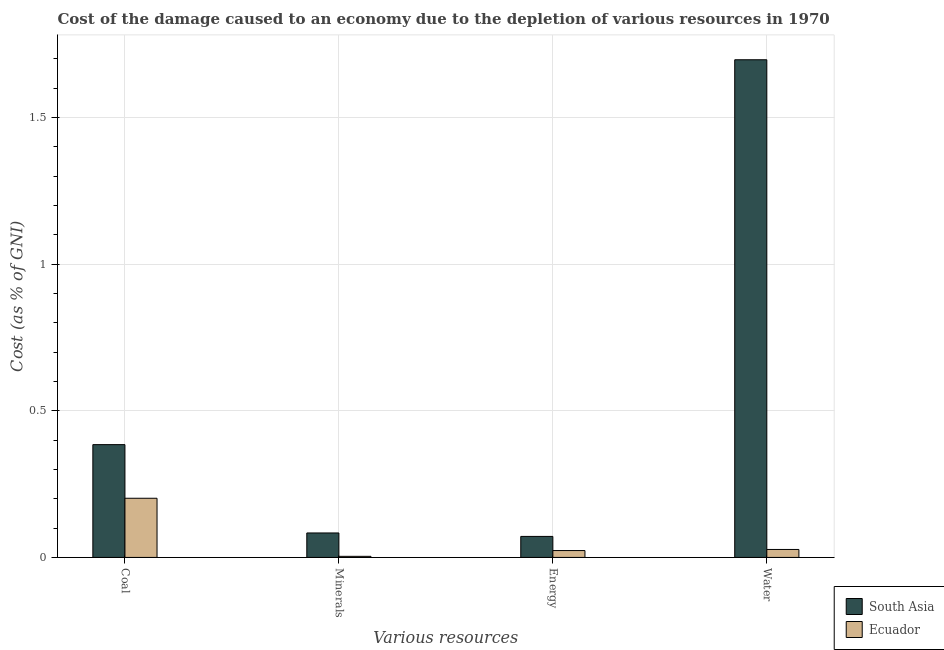How many different coloured bars are there?
Your answer should be compact. 2. Are the number of bars on each tick of the X-axis equal?
Give a very brief answer. Yes. How many bars are there on the 3rd tick from the right?
Your answer should be very brief. 2. What is the label of the 2nd group of bars from the left?
Offer a terse response. Minerals. What is the cost of damage due to depletion of water in Ecuador?
Ensure brevity in your answer.  0.03. Across all countries, what is the maximum cost of damage due to depletion of coal?
Your answer should be very brief. 0.38. Across all countries, what is the minimum cost of damage due to depletion of energy?
Ensure brevity in your answer.  0.02. In which country was the cost of damage due to depletion of minerals minimum?
Offer a very short reply. Ecuador. What is the total cost of damage due to depletion of water in the graph?
Your answer should be very brief. 1.72. What is the difference between the cost of damage due to depletion of coal in Ecuador and that in South Asia?
Offer a very short reply. -0.18. What is the difference between the cost of damage due to depletion of water in Ecuador and the cost of damage due to depletion of coal in South Asia?
Provide a short and direct response. -0.36. What is the average cost of damage due to depletion of minerals per country?
Your answer should be very brief. 0.04. What is the difference between the cost of damage due to depletion of energy and cost of damage due to depletion of minerals in Ecuador?
Your answer should be compact. 0.02. In how many countries, is the cost of damage due to depletion of water greater than 0.1 %?
Offer a very short reply. 1. What is the ratio of the cost of damage due to depletion of water in Ecuador to that in South Asia?
Your answer should be very brief. 0.02. What is the difference between the highest and the second highest cost of damage due to depletion of energy?
Your answer should be compact. 0.05. What is the difference between the highest and the lowest cost of damage due to depletion of minerals?
Make the answer very short. 0.08. In how many countries, is the cost of damage due to depletion of coal greater than the average cost of damage due to depletion of coal taken over all countries?
Your answer should be compact. 1. Is the sum of the cost of damage due to depletion of coal in Ecuador and South Asia greater than the maximum cost of damage due to depletion of water across all countries?
Provide a succinct answer. No. What does the 1st bar from the left in Energy represents?
Give a very brief answer. South Asia. What does the 1st bar from the right in Coal represents?
Your answer should be compact. Ecuador. How many countries are there in the graph?
Give a very brief answer. 2. Are the values on the major ticks of Y-axis written in scientific E-notation?
Make the answer very short. No. Does the graph contain any zero values?
Offer a very short reply. No. Where does the legend appear in the graph?
Offer a terse response. Bottom right. What is the title of the graph?
Give a very brief answer. Cost of the damage caused to an economy due to the depletion of various resources in 1970 . What is the label or title of the X-axis?
Your answer should be very brief. Various resources. What is the label or title of the Y-axis?
Offer a terse response. Cost (as % of GNI). What is the Cost (as % of GNI) of South Asia in Coal?
Offer a very short reply. 0.38. What is the Cost (as % of GNI) in Ecuador in Coal?
Your answer should be very brief. 0.2. What is the Cost (as % of GNI) in South Asia in Minerals?
Give a very brief answer. 0.08. What is the Cost (as % of GNI) in Ecuador in Minerals?
Provide a short and direct response. 0. What is the Cost (as % of GNI) of South Asia in Energy?
Provide a succinct answer. 0.07. What is the Cost (as % of GNI) in Ecuador in Energy?
Keep it short and to the point. 0.02. What is the Cost (as % of GNI) in South Asia in Water?
Make the answer very short. 1.7. What is the Cost (as % of GNI) of Ecuador in Water?
Provide a short and direct response. 0.03. Across all Various resources, what is the maximum Cost (as % of GNI) in South Asia?
Ensure brevity in your answer.  1.7. Across all Various resources, what is the maximum Cost (as % of GNI) of Ecuador?
Keep it short and to the point. 0.2. Across all Various resources, what is the minimum Cost (as % of GNI) in South Asia?
Your answer should be compact. 0.07. Across all Various resources, what is the minimum Cost (as % of GNI) of Ecuador?
Offer a terse response. 0. What is the total Cost (as % of GNI) in South Asia in the graph?
Your answer should be very brief. 2.24. What is the total Cost (as % of GNI) in Ecuador in the graph?
Provide a short and direct response. 0.26. What is the difference between the Cost (as % of GNI) of South Asia in Coal and that in Minerals?
Make the answer very short. 0.3. What is the difference between the Cost (as % of GNI) of Ecuador in Coal and that in Minerals?
Provide a short and direct response. 0.2. What is the difference between the Cost (as % of GNI) in South Asia in Coal and that in Energy?
Ensure brevity in your answer.  0.31. What is the difference between the Cost (as % of GNI) of Ecuador in Coal and that in Energy?
Your answer should be compact. 0.18. What is the difference between the Cost (as % of GNI) in South Asia in Coal and that in Water?
Ensure brevity in your answer.  -1.31. What is the difference between the Cost (as % of GNI) in Ecuador in Coal and that in Water?
Ensure brevity in your answer.  0.17. What is the difference between the Cost (as % of GNI) of South Asia in Minerals and that in Energy?
Offer a very short reply. 0.01. What is the difference between the Cost (as % of GNI) of Ecuador in Minerals and that in Energy?
Keep it short and to the point. -0.02. What is the difference between the Cost (as % of GNI) in South Asia in Minerals and that in Water?
Keep it short and to the point. -1.61. What is the difference between the Cost (as % of GNI) of Ecuador in Minerals and that in Water?
Offer a very short reply. -0.02. What is the difference between the Cost (as % of GNI) in South Asia in Energy and that in Water?
Make the answer very short. -1.63. What is the difference between the Cost (as % of GNI) of Ecuador in Energy and that in Water?
Keep it short and to the point. -0. What is the difference between the Cost (as % of GNI) of South Asia in Coal and the Cost (as % of GNI) of Ecuador in Minerals?
Ensure brevity in your answer.  0.38. What is the difference between the Cost (as % of GNI) of South Asia in Coal and the Cost (as % of GNI) of Ecuador in Energy?
Offer a terse response. 0.36. What is the difference between the Cost (as % of GNI) of South Asia in Coal and the Cost (as % of GNI) of Ecuador in Water?
Give a very brief answer. 0.36. What is the difference between the Cost (as % of GNI) in South Asia in Minerals and the Cost (as % of GNI) in Ecuador in Energy?
Your response must be concise. 0.06. What is the difference between the Cost (as % of GNI) of South Asia in Minerals and the Cost (as % of GNI) of Ecuador in Water?
Give a very brief answer. 0.06. What is the difference between the Cost (as % of GNI) of South Asia in Energy and the Cost (as % of GNI) of Ecuador in Water?
Give a very brief answer. 0.04. What is the average Cost (as % of GNI) of South Asia per Various resources?
Give a very brief answer. 0.56. What is the average Cost (as % of GNI) of Ecuador per Various resources?
Offer a terse response. 0.06. What is the difference between the Cost (as % of GNI) of South Asia and Cost (as % of GNI) of Ecuador in Coal?
Provide a short and direct response. 0.18. What is the difference between the Cost (as % of GNI) in South Asia and Cost (as % of GNI) in Ecuador in Minerals?
Your answer should be very brief. 0.08. What is the difference between the Cost (as % of GNI) of South Asia and Cost (as % of GNI) of Ecuador in Energy?
Your answer should be compact. 0.05. What is the difference between the Cost (as % of GNI) in South Asia and Cost (as % of GNI) in Ecuador in Water?
Keep it short and to the point. 1.67. What is the ratio of the Cost (as % of GNI) in South Asia in Coal to that in Minerals?
Offer a very short reply. 4.61. What is the ratio of the Cost (as % of GNI) in Ecuador in Coal to that in Minerals?
Make the answer very short. 54.54. What is the ratio of the Cost (as % of GNI) of South Asia in Coal to that in Energy?
Keep it short and to the point. 5.37. What is the ratio of the Cost (as % of GNI) of Ecuador in Coal to that in Energy?
Offer a terse response. 8.6. What is the ratio of the Cost (as % of GNI) in South Asia in Coal to that in Water?
Your answer should be very brief. 0.23. What is the ratio of the Cost (as % of GNI) of Ecuador in Coal to that in Water?
Your answer should be compact. 7.43. What is the ratio of the Cost (as % of GNI) in South Asia in Minerals to that in Energy?
Provide a short and direct response. 1.16. What is the ratio of the Cost (as % of GNI) in Ecuador in Minerals to that in Energy?
Provide a succinct answer. 0.16. What is the ratio of the Cost (as % of GNI) in South Asia in Minerals to that in Water?
Keep it short and to the point. 0.05. What is the ratio of the Cost (as % of GNI) of Ecuador in Minerals to that in Water?
Make the answer very short. 0.14. What is the ratio of the Cost (as % of GNI) in South Asia in Energy to that in Water?
Your answer should be very brief. 0.04. What is the ratio of the Cost (as % of GNI) of Ecuador in Energy to that in Water?
Provide a succinct answer. 0.86. What is the difference between the highest and the second highest Cost (as % of GNI) of South Asia?
Provide a short and direct response. 1.31. What is the difference between the highest and the second highest Cost (as % of GNI) of Ecuador?
Make the answer very short. 0.17. What is the difference between the highest and the lowest Cost (as % of GNI) of South Asia?
Provide a short and direct response. 1.63. What is the difference between the highest and the lowest Cost (as % of GNI) in Ecuador?
Ensure brevity in your answer.  0.2. 